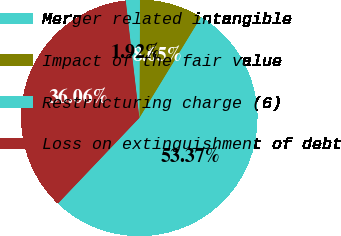Convert chart. <chart><loc_0><loc_0><loc_500><loc_500><pie_chart><fcel>Merger related intangible<fcel>Impact of the fair value<fcel>Restructuring charge (6)<fcel>Loss on extinguishment of debt<nl><fcel>53.37%<fcel>8.65%<fcel>1.92%<fcel>36.06%<nl></chart> 